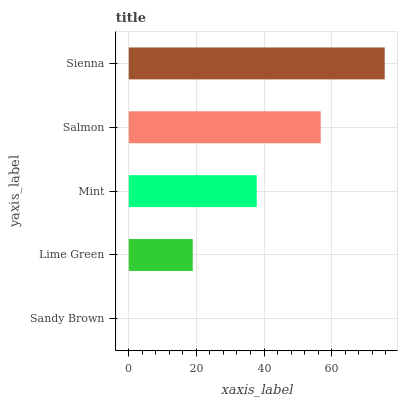Is Sandy Brown the minimum?
Answer yes or no. Yes. Is Sienna the maximum?
Answer yes or no. Yes. Is Lime Green the minimum?
Answer yes or no. No. Is Lime Green the maximum?
Answer yes or no. No. Is Lime Green greater than Sandy Brown?
Answer yes or no. Yes. Is Sandy Brown less than Lime Green?
Answer yes or no. Yes. Is Sandy Brown greater than Lime Green?
Answer yes or no. No. Is Lime Green less than Sandy Brown?
Answer yes or no. No. Is Mint the high median?
Answer yes or no. Yes. Is Mint the low median?
Answer yes or no. Yes. Is Sienna the high median?
Answer yes or no. No. Is Lime Green the low median?
Answer yes or no. No. 